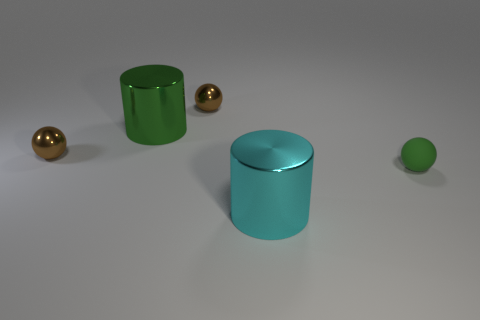What could be the function of these objects in a real-world setting? As the objects appear simplistic and ornamental, one might speculate that, in a real-world setting, the cylinders could serve as decorative containers or pedestals, while the spheres might be sculptural elements designed to add visual interest to an environment. 